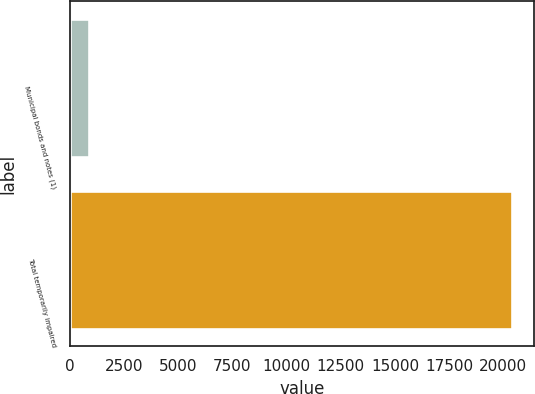<chart> <loc_0><loc_0><loc_500><loc_500><bar_chart><fcel>Municipal bonds and notes (1)<fcel>Total temporarily impaired<nl><fcel>893<fcel>20396<nl></chart> 